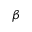Convert formula to latex. <formula><loc_0><loc_0><loc_500><loc_500>\beta</formula> 